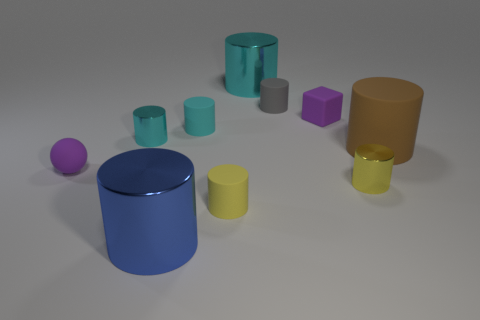Subtract all cyan cylinders. How many cylinders are left? 5 Subtract all blue balls. How many yellow cylinders are left? 2 Subtract 5 cylinders. How many cylinders are left? 3 Subtract all yellow cylinders. How many cylinders are left? 6 Subtract all cubes. How many objects are left? 9 Subtract all cyan cylinders. Subtract all red blocks. How many cylinders are left? 5 Add 5 big blue cylinders. How many big blue cylinders are left? 6 Add 6 blocks. How many blocks exist? 7 Subtract 0 purple cylinders. How many objects are left? 10 Subtract all blue matte things. Subtract all tiny rubber blocks. How many objects are left? 9 